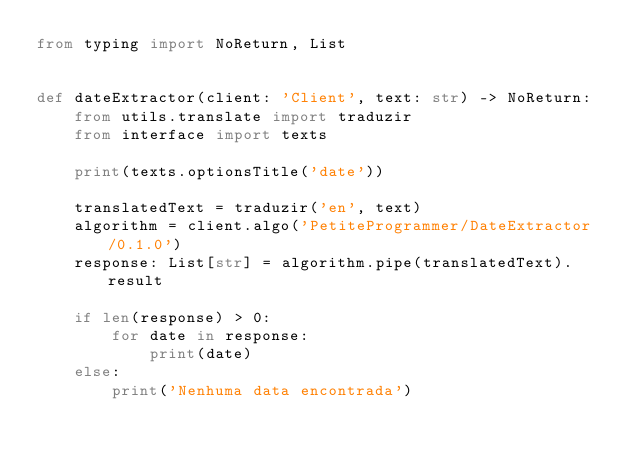Convert code to text. <code><loc_0><loc_0><loc_500><loc_500><_Python_>from typing import NoReturn, List


def dateExtractor(client: 'Client', text: str) -> NoReturn:
    from utils.translate import traduzir
    from interface import texts

    print(texts.optionsTitle('date'))

    translatedText = traduzir('en', text)
    algorithm = client.algo('PetiteProgrammer/DateExtractor/0.1.0')
    response: List[str] = algorithm.pipe(translatedText).result

    if len(response) > 0:
        for date in response:
            print(date)
    else:
        print('Nenhuma data encontrada')
</code> 